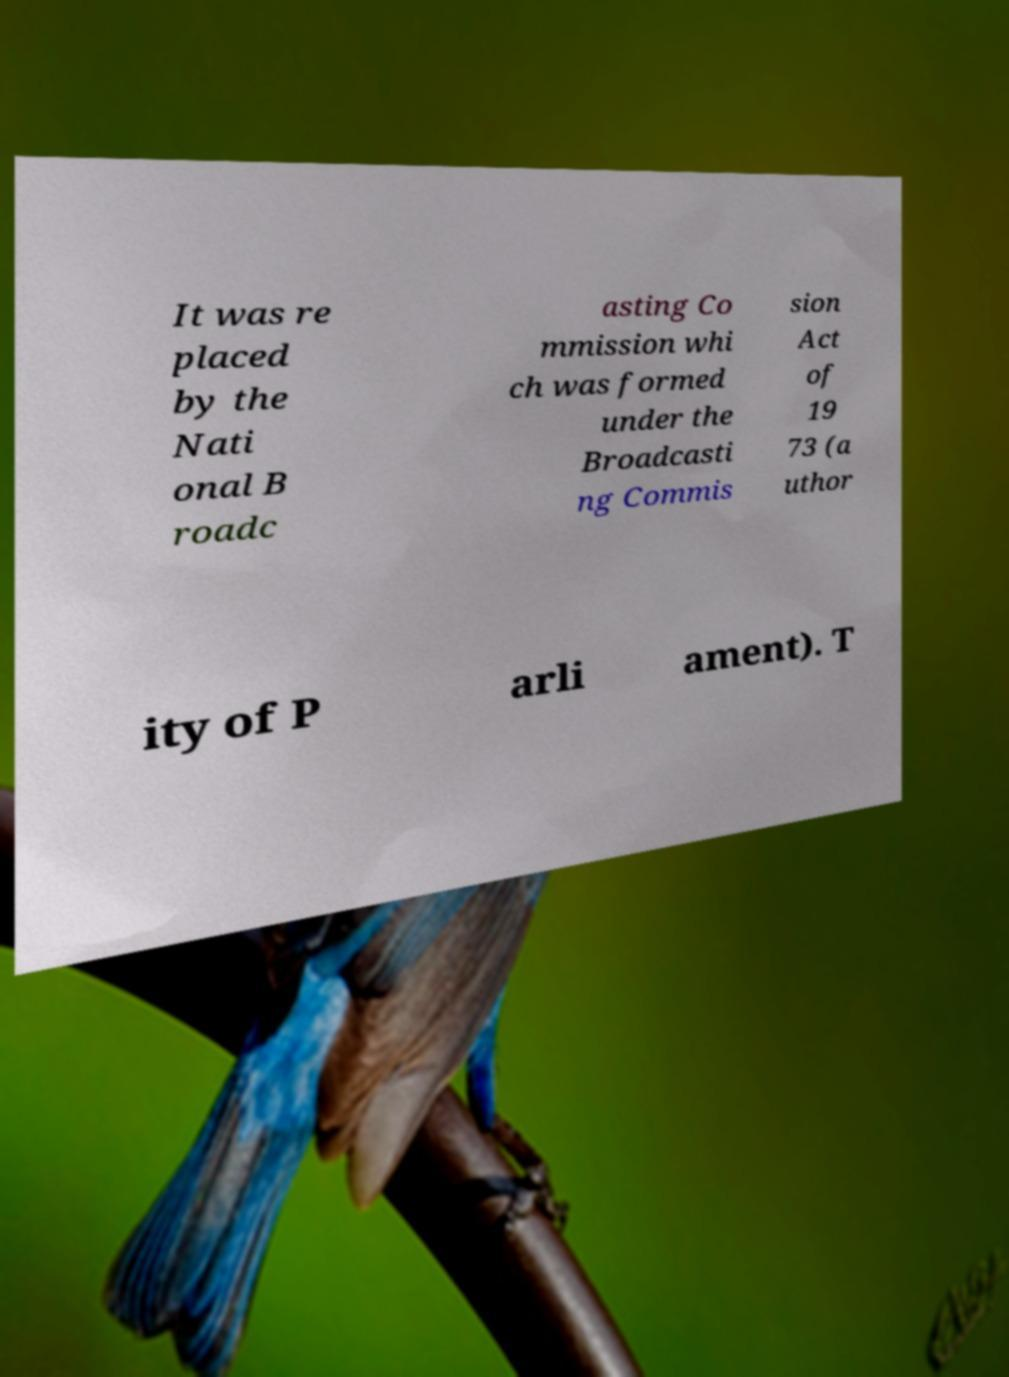Could you extract and type out the text from this image? It was re placed by the Nati onal B roadc asting Co mmission whi ch was formed under the Broadcasti ng Commis sion Act of 19 73 (a uthor ity of P arli ament). T 